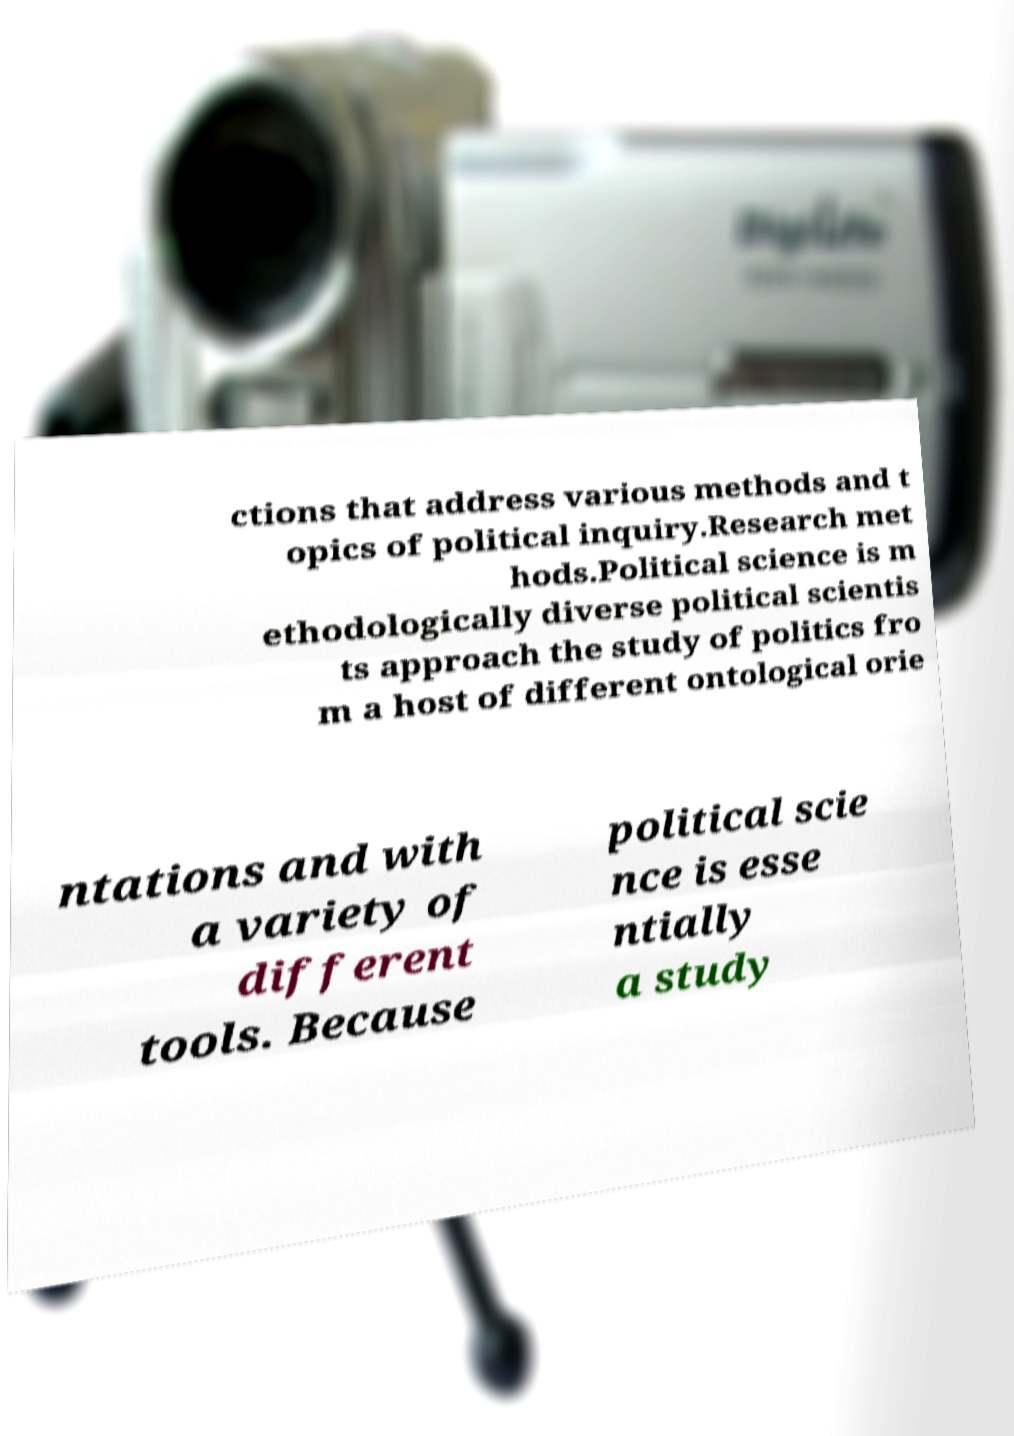What messages or text are displayed in this image? I need them in a readable, typed format. ctions that address various methods and t opics of political inquiry.Research met hods.Political science is m ethodologically diverse political scientis ts approach the study of politics fro m a host of different ontological orie ntations and with a variety of different tools. Because political scie nce is esse ntially a study 